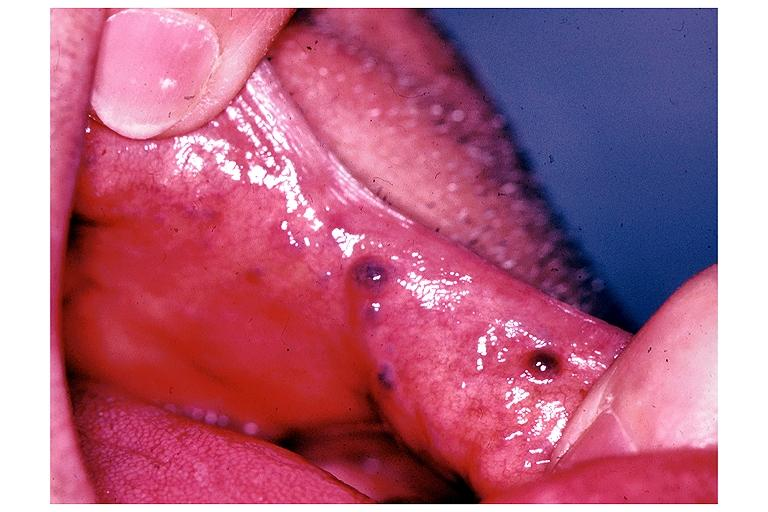what does this image show?
Answer the question using a single word or phrase. Varix 